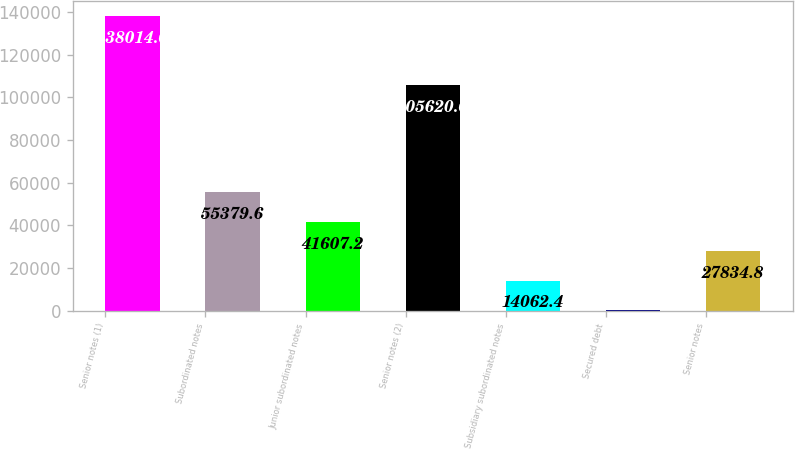Convert chart to OTSL. <chart><loc_0><loc_0><loc_500><loc_500><bar_chart><fcel>Senior notes (1)<fcel>Subordinated notes<fcel>Junior subordinated notes<fcel>Senior notes (2)<fcel>Subsidiary subordinated notes<fcel>Secured debt<fcel>Senior notes<nl><fcel>138014<fcel>55379.6<fcel>41607.2<fcel>105620<fcel>14062.4<fcel>290<fcel>27834.8<nl></chart> 